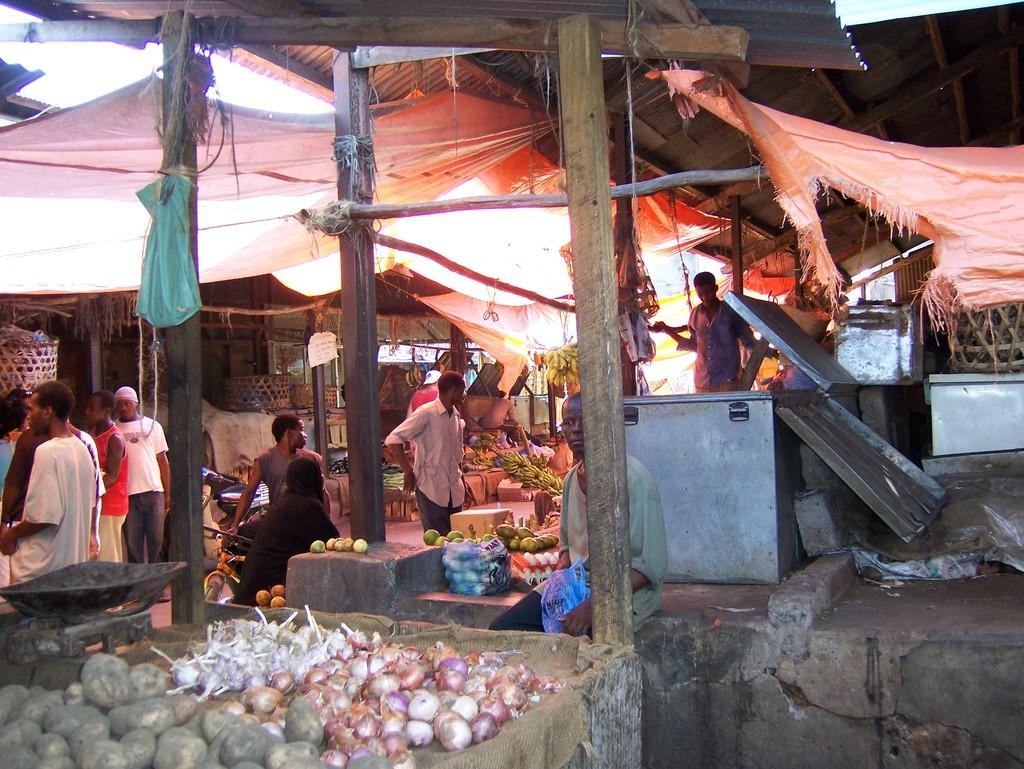What type of market is depicted in the image? The image depicts a vegetable and fruit market. Can you describe the people present in the market? There are people present in the market, but their specific actions or roles are not mentioned in the facts. What type of containers can be seen in the market? Containers are visible in the market, but their specific purpose or contents are not mentioned in the facts. Which vegetables are present in the market? Onions, garlic, potatoes, and other vegetables are present in the market. Which fruits are present in the market? Bananas are present in the market. What type of equipment is visible in the market? A weighing machine is visible in the market. What other items are present in the market? Eggs are present in the market. Can you describe the tail of the animal in the market? There is no animal with a tail present in the image; it depicts a vegetable and fruit market. 